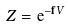<formula> <loc_0><loc_0><loc_500><loc_500>Z = { \mathrm e } ^ { - { \mathbf f } V }</formula> 